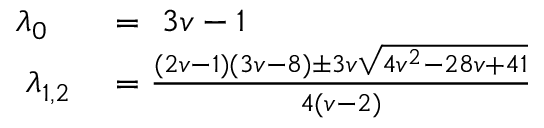<formula> <loc_0><loc_0><loc_500><loc_500>\begin{array} { r l } { \lambda _ { 0 } } & = 3 v - 1 } \\ { \lambda _ { 1 , 2 } } & = \frac { ( 2 v - 1 ) ( 3 v - 8 ) \pm 3 v \sqrt { 4 v ^ { 2 } - 2 8 v + 4 1 } } { 4 ( v - 2 ) } } \end{array}</formula> 